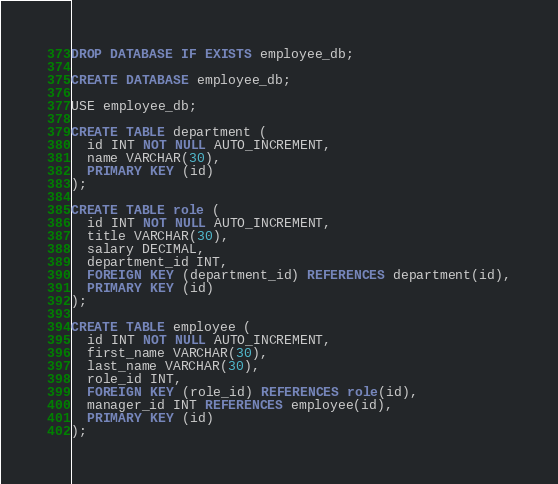<code> <loc_0><loc_0><loc_500><loc_500><_SQL_>DROP DATABASE IF EXISTS employee_db;

CREATE DATABASE employee_db;

USE employee_db;

CREATE TABLE department (
  id INT NOT NULL AUTO_INCREMENT,
  name VARCHAR(30),
  PRIMARY KEY (id)
);

CREATE TABLE role (
  id INT NOT NULL AUTO_INCREMENT,
  title VARCHAR(30),
  salary DECIMAL,
  department_id INT,
  FOREIGN KEY (department_id) REFERENCES department(id),
  PRIMARY KEY (id) 
);

CREATE TABLE employee (
  id INT NOT NULL AUTO_INCREMENT,
  first_name VARCHAR(30),
  last_name VARCHAR(30),
  role_id INT,
  FOREIGN KEY (role_id) REFERENCES role(id),
  manager_id INT REFERENCES employee(id),
  PRIMARY KEY (id)
);</code> 